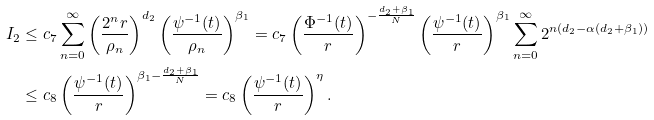Convert formula to latex. <formula><loc_0><loc_0><loc_500><loc_500>I _ { 2 } & \leq c _ { 7 } \sum _ { n = 0 } ^ { \infty } \left ( \frac { 2 ^ { n } r } { \rho _ { n } } \right ) ^ { d _ { 2 } } \left ( \frac { \psi ^ { - 1 } ( t ) } { \rho _ { n } } \right ) ^ { \beta _ { 1 } } = c _ { 7 } \left ( \frac { \Phi ^ { - 1 } ( t ) } { r } \right ) ^ { - \frac { d _ { 2 } + \beta _ { 1 } } { N } } \left ( \frac { \psi ^ { - 1 } ( t ) } { r } \right ) ^ { \beta _ { 1 } } \sum _ { n = 0 } ^ { \infty } 2 ^ { n ( d _ { 2 } - \alpha ( d _ { 2 } + \beta _ { 1 } ) ) } \\ & \leq c _ { 8 } \left ( \frac { \psi ^ { - 1 } ( t ) } { r } \right ) ^ { \beta _ { 1 } - \frac { d _ { 2 } + \beta _ { 1 } } { N } } = c _ { 8 } \left ( \frac { \psi ^ { - 1 } ( t ) } { r } \right ) ^ { \eta } .</formula> 